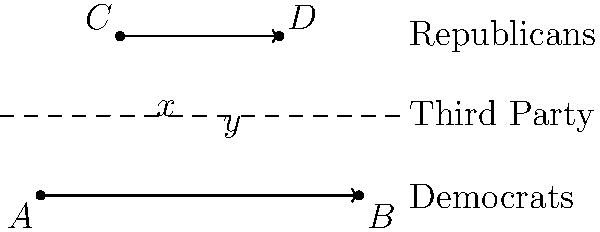In the political landscape diagram, three lines represent the Democrats, Republicans, and a growing Third Party. The Third Party line intersects the two major party lines, forming alternate interior angles. If the angle representing the Third Party's similarity to the Democrats is $x°$ and its similarity to the Republicans is $y°$, what is the sum of $x$ and $y$? To solve this problem, we need to understand the properties of alternate interior angles formed when a line intersects two parallel lines. Here's a step-by-step explanation:

1. The Democrats and Republicans are represented by parallel lines in this diagram.
2. The Third Party line acts as a transversal, intersecting both parallel lines.
3. When a transversal intersects two parallel lines, the alternate interior angles are congruent.
4. In this case, angle $x$ and the angle opposite to $y$ (let's call it $y'$) are alternate interior angles.
5. Therefore, $x = y'$.
6. We know that angles on a straight line sum to 180°.
7. So, $y + y' = 180°$.
8. Since $x = y'$, we can substitute: $y + x = 180°$.
9. Therefore, the sum of $x$ and $y$ is always 180°, regardless of their individual measures.

This result symbolizes that regardless of how similar or different the Third Party is to either major party, its total relationship to both parties remains constant, emphasizing the importance of maintaining a distinct identity while navigating the established political spectrum.
Answer: $180°$ 